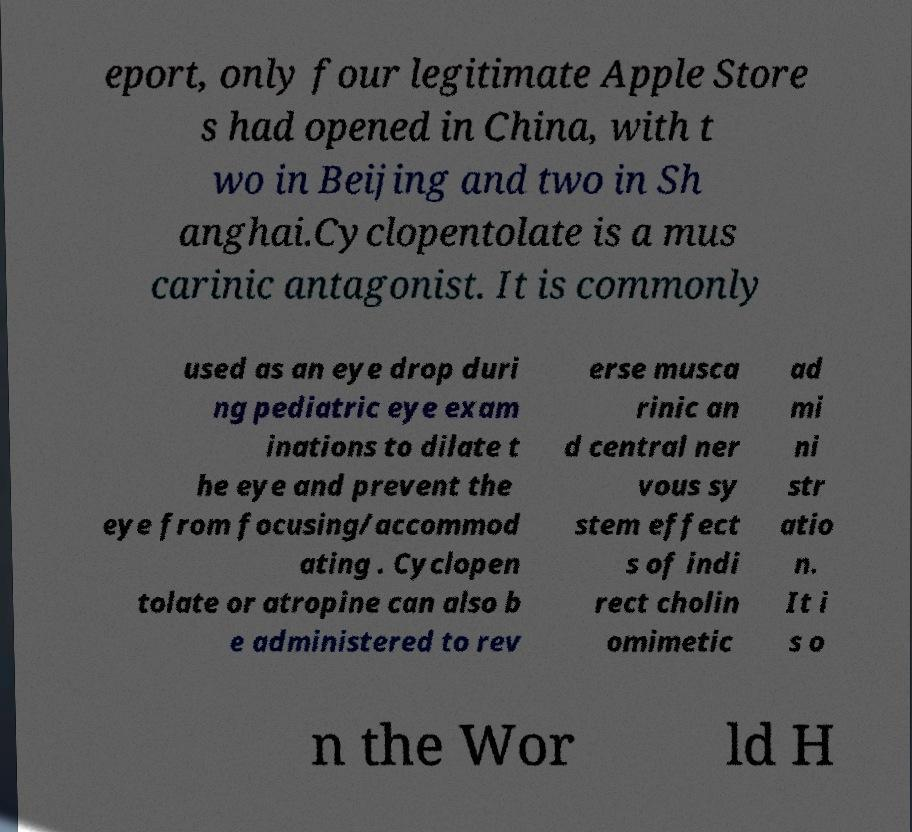Could you assist in decoding the text presented in this image and type it out clearly? eport, only four legitimate Apple Store s had opened in China, with t wo in Beijing and two in Sh anghai.Cyclopentolate is a mus carinic antagonist. It is commonly used as an eye drop duri ng pediatric eye exam inations to dilate t he eye and prevent the eye from focusing/accommod ating . Cyclopen tolate or atropine can also b e administered to rev erse musca rinic an d central ner vous sy stem effect s of indi rect cholin omimetic ad mi ni str atio n. It i s o n the Wor ld H 